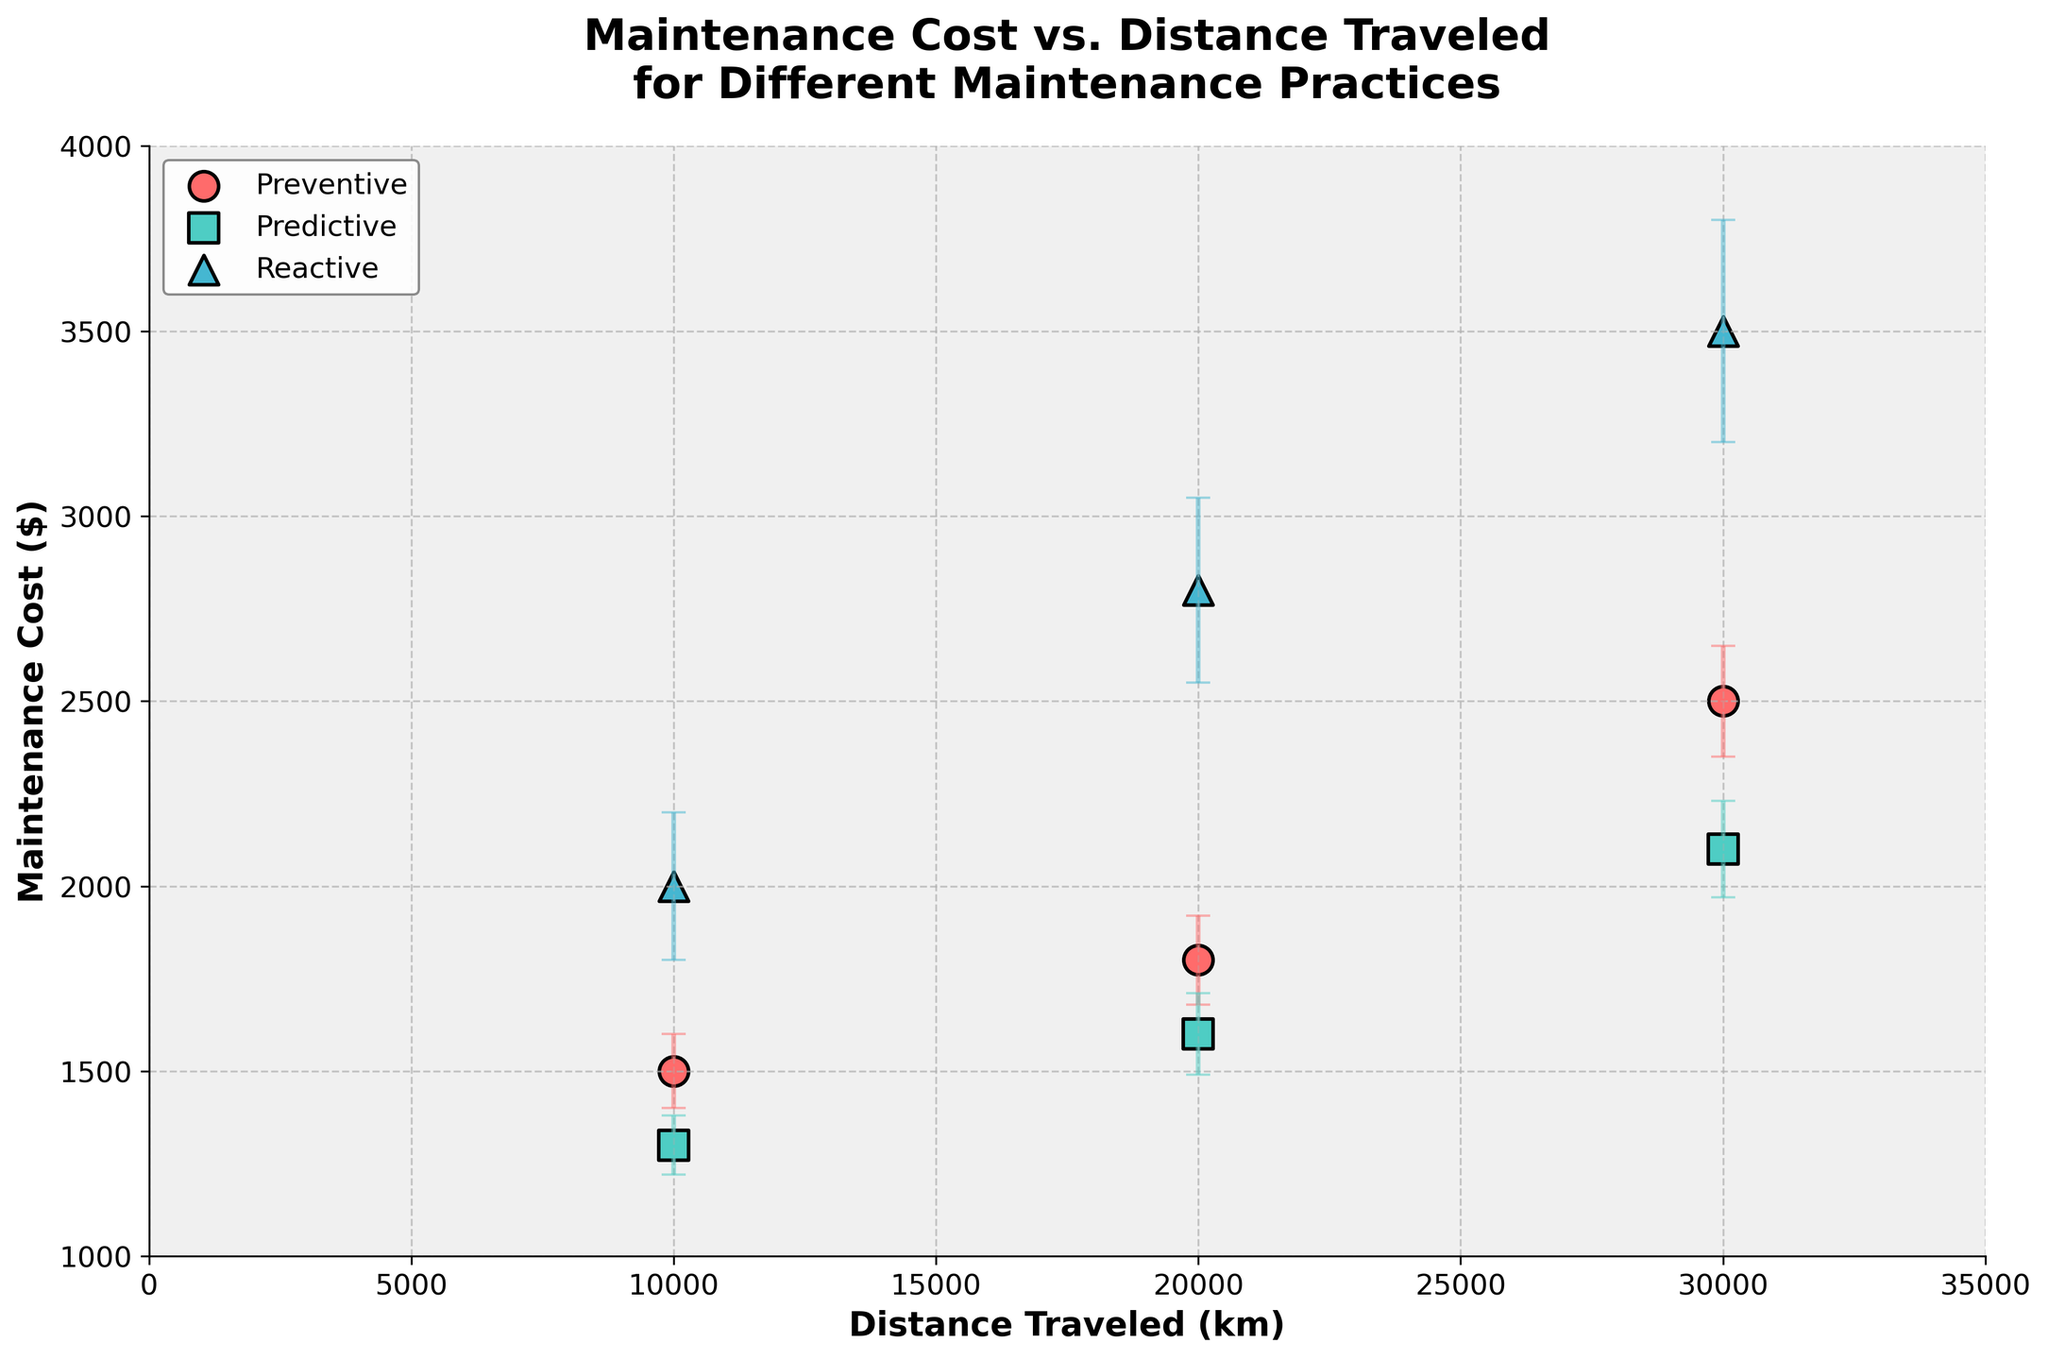How many data points are displayed for each maintenance practice? By examining the figure, you can see the differing colors and markers for each group. There are three markers for each maintenance practice: Preventive (circles), Predictive (squares), and Reactive (triangles).
Answer: 3 for each practice What is the title of the plot? The title of the plot is displayed prominently at the top of the figure. It says "Maintenance Cost vs. Distance Traveled for Different Maintenance Practices."
Answer: Maintenance Cost vs. Distance Traveled for Different Maintenance Practices Which maintenance practice has the lowest maintenance cost at 10,000 km? Checking the y-values at the x-value of 10,000 km, the lowest point belongs to the Predictive Maintenance practice.
Answer: Predictive What is the difference in maintenance cost for the Reactive practice between 10,000 km and 30,000 km? At 10,000 km, the maintenance cost is $2,000 and at 30,000 km it is $3,500. The difference is $3,500 - $2,000.
Answer: $1,500 What is the range of error for Predictive maintenance practice at 20,000 km? For Predictive maintenance at 20,000 km, the error bar extends from $1,490 to $1,710. This means the ErrorMargin is 110 (which is ±55) from the main value.
Answer: ±110 Among the three practices, which one shows the highest increase in maintenance cost as distance traveled increases from 10,000 km to 30,000 km? Comparing the slopes, from 10,000 km to 30,000 km: Preventive goes from $1,500 to $2,500 (increase of $1,000), Predictive from $1,300 to $2,100 (increase of $800), Reactive from $2,000 to $3,500 (increase of $1,500).
Answer: Reactive What is the average maintenance cost for Preventive maintenance for all distances? Averaging the three maintenance costs for Preventive practice: (1500 + 1800 + 2500) / 3 = 1933.33.
Answer: $1933.33 Which maintenance practice shows the least variability in costs as indicated by error bars? Predictive practice has the smallest error margins across all distances, indicating the least variability.
Answer: Predictive 